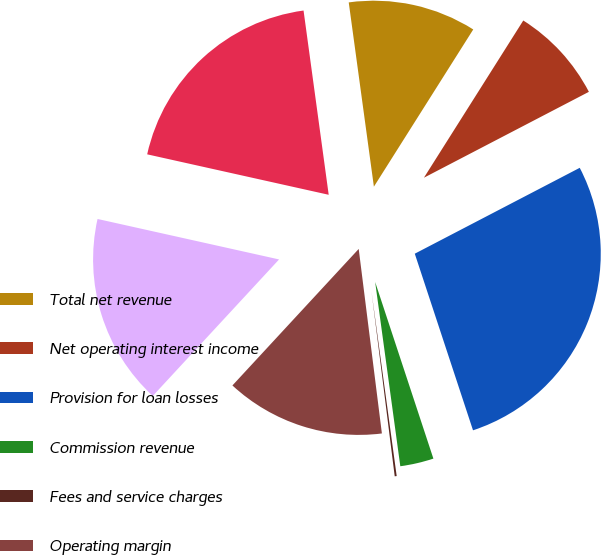Convert chart to OTSL. <chart><loc_0><loc_0><loc_500><loc_500><pie_chart><fcel>Total net revenue<fcel>Net operating interest income<fcel>Provision for loan losses<fcel>Commission revenue<fcel>Fees and service charges<fcel>Operating margin<fcel>Net income (loss)<fcel>Diluted net earnings (loss)<nl><fcel>11.13%<fcel>8.39%<fcel>27.57%<fcel>2.91%<fcel>0.17%<fcel>13.87%<fcel>16.61%<fcel>19.35%<nl></chart> 